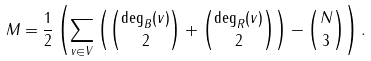Convert formula to latex. <formula><loc_0><loc_0><loc_500><loc_500>M = \frac { 1 } { 2 } \left ( \sum _ { v \in V } \left ( \binom { \deg _ { B } ( v ) } 2 + \binom { \deg _ { R } ( v ) } 2 \right ) - \binom { N } { 3 } \right ) .</formula> 